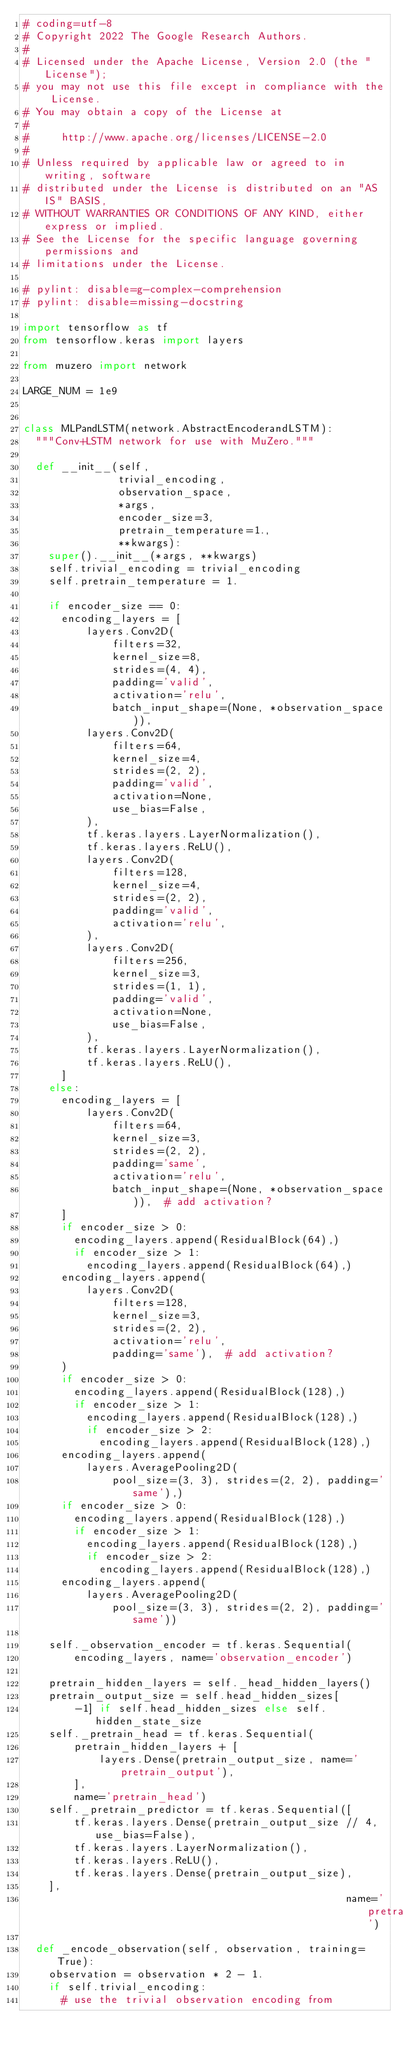<code> <loc_0><loc_0><loc_500><loc_500><_Python_># coding=utf-8
# Copyright 2022 The Google Research Authors.
#
# Licensed under the Apache License, Version 2.0 (the "License");
# you may not use this file except in compliance with the License.
# You may obtain a copy of the License at
#
#     http://www.apache.org/licenses/LICENSE-2.0
#
# Unless required by applicable law or agreed to in writing, software
# distributed under the License is distributed on an "AS IS" BASIS,
# WITHOUT WARRANTIES OR CONDITIONS OF ANY KIND, either express or implied.
# See the License for the specific language governing permissions and
# limitations under the License.

# pylint: disable=g-complex-comprehension
# pylint: disable=missing-docstring

import tensorflow as tf
from tensorflow.keras import layers

from muzero import network

LARGE_NUM = 1e9


class MLPandLSTM(network.AbstractEncoderandLSTM):
  """Conv+LSTM network for use with MuZero."""

  def __init__(self,
               trivial_encoding,
               observation_space,
               *args,
               encoder_size=3,
               pretrain_temperature=1.,
               **kwargs):
    super().__init__(*args, **kwargs)
    self.trivial_encoding = trivial_encoding
    self.pretrain_temperature = 1.

    if encoder_size == 0:
      encoding_layers = [
          layers.Conv2D(
              filters=32,
              kernel_size=8,
              strides=(4, 4),
              padding='valid',
              activation='relu',
              batch_input_shape=(None, *observation_space)),
          layers.Conv2D(
              filters=64,
              kernel_size=4,
              strides=(2, 2),
              padding='valid',
              activation=None,
              use_bias=False,
          ),
          tf.keras.layers.LayerNormalization(),
          tf.keras.layers.ReLU(),
          layers.Conv2D(
              filters=128,
              kernel_size=4,
              strides=(2, 2),
              padding='valid',
              activation='relu',
          ),
          layers.Conv2D(
              filters=256,
              kernel_size=3,
              strides=(1, 1),
              padding='valid',
              activation=None,
              use_bias=False,
          ),
          tf.keras.layers.LayerNormalization(),
          tf.keras.layers.ReLU(),
      ]
    else:
      encoding_layers = [
          layers.Conv2D(
              filters=64,
              kernel_size=3,
              strides=(2, 2),
              padding='same',
              activation='relu',
              batch_input_shape=(None, *observation_space)),  # add activation?
      ]
      if encoder_size > 0:
        encoding_layers.append(ResidualBlock(64),)
        if encoder_size > 1:
          encoding_layers.append(ResidualBlock(64),)
      encoding_layers.append(
          layers.Conv2D(
              filters=128,
              kernel_size=3,
              strides=(2, 2),
              activation='relu',
              padding='same'),  # add activation?
      )
      if encoder_size > 0:
        encoding_layers.append(ResidualBlock(128),)
        if encoder_size > 1:
          encoding_layers.append(ResidualBlock(128),)
          if encoder_size > 2:
            encoding_layers.append(ResidualBlock(128),)
      encoding_layers.append(
          layers.AveragePooling2D(
              pool_size=(3, 3), strides=(2, 2), padding='same'),)
      if encoder_size > 0:
        encoding_layers.append(ResidualBlock(128),)
        if encoder_size > 1:
          encoding_layers.append(ResidualBlock(128),)
          if encoder_size > 2:
            encoding_layers.append(ResidualBlock(128),)
      encoding_layers.append(
          layers.AveragePooling2D(
              pool_size=(3, 3), strides=(2, 2), padding='same'))

    self._observation_encoder = tf.keras.Sequential(
        encoding_layers, name='observation_encoder')

    pretrain_hidden_layers = self._head_hidden_layers()
    pretrain_output_size = self.head_hidden_sizes[
        -1] if self.head_hidden_sizes else self.hidden_state_size
    self._pretrain_head = tf.keras.Sequential(
        pretrain_hidden_layers + [
            layers.Dense(pretrain_output_size, name='pretrain_output'),
        ],
        name='pretrain_head')
    self._pretrain_predictor = tf.keras.Sequential([
        tf.keras.layers.Dense(pretrain_output_size // 4, use_bias=False),
        tf.keras.layers.LayerNormalization(),
        tf.keras.layers.ReLU(),
        tf.keras.layers.Dense(pretrain_output_size),
    ],
                                                   name='pretrain_predictor')

  def _encode_observation(self, observation, training=True):
    observation = observation * 2 - 1.
    if self.trivial_encoding:
      # use the trivial observation encoding from</code> 